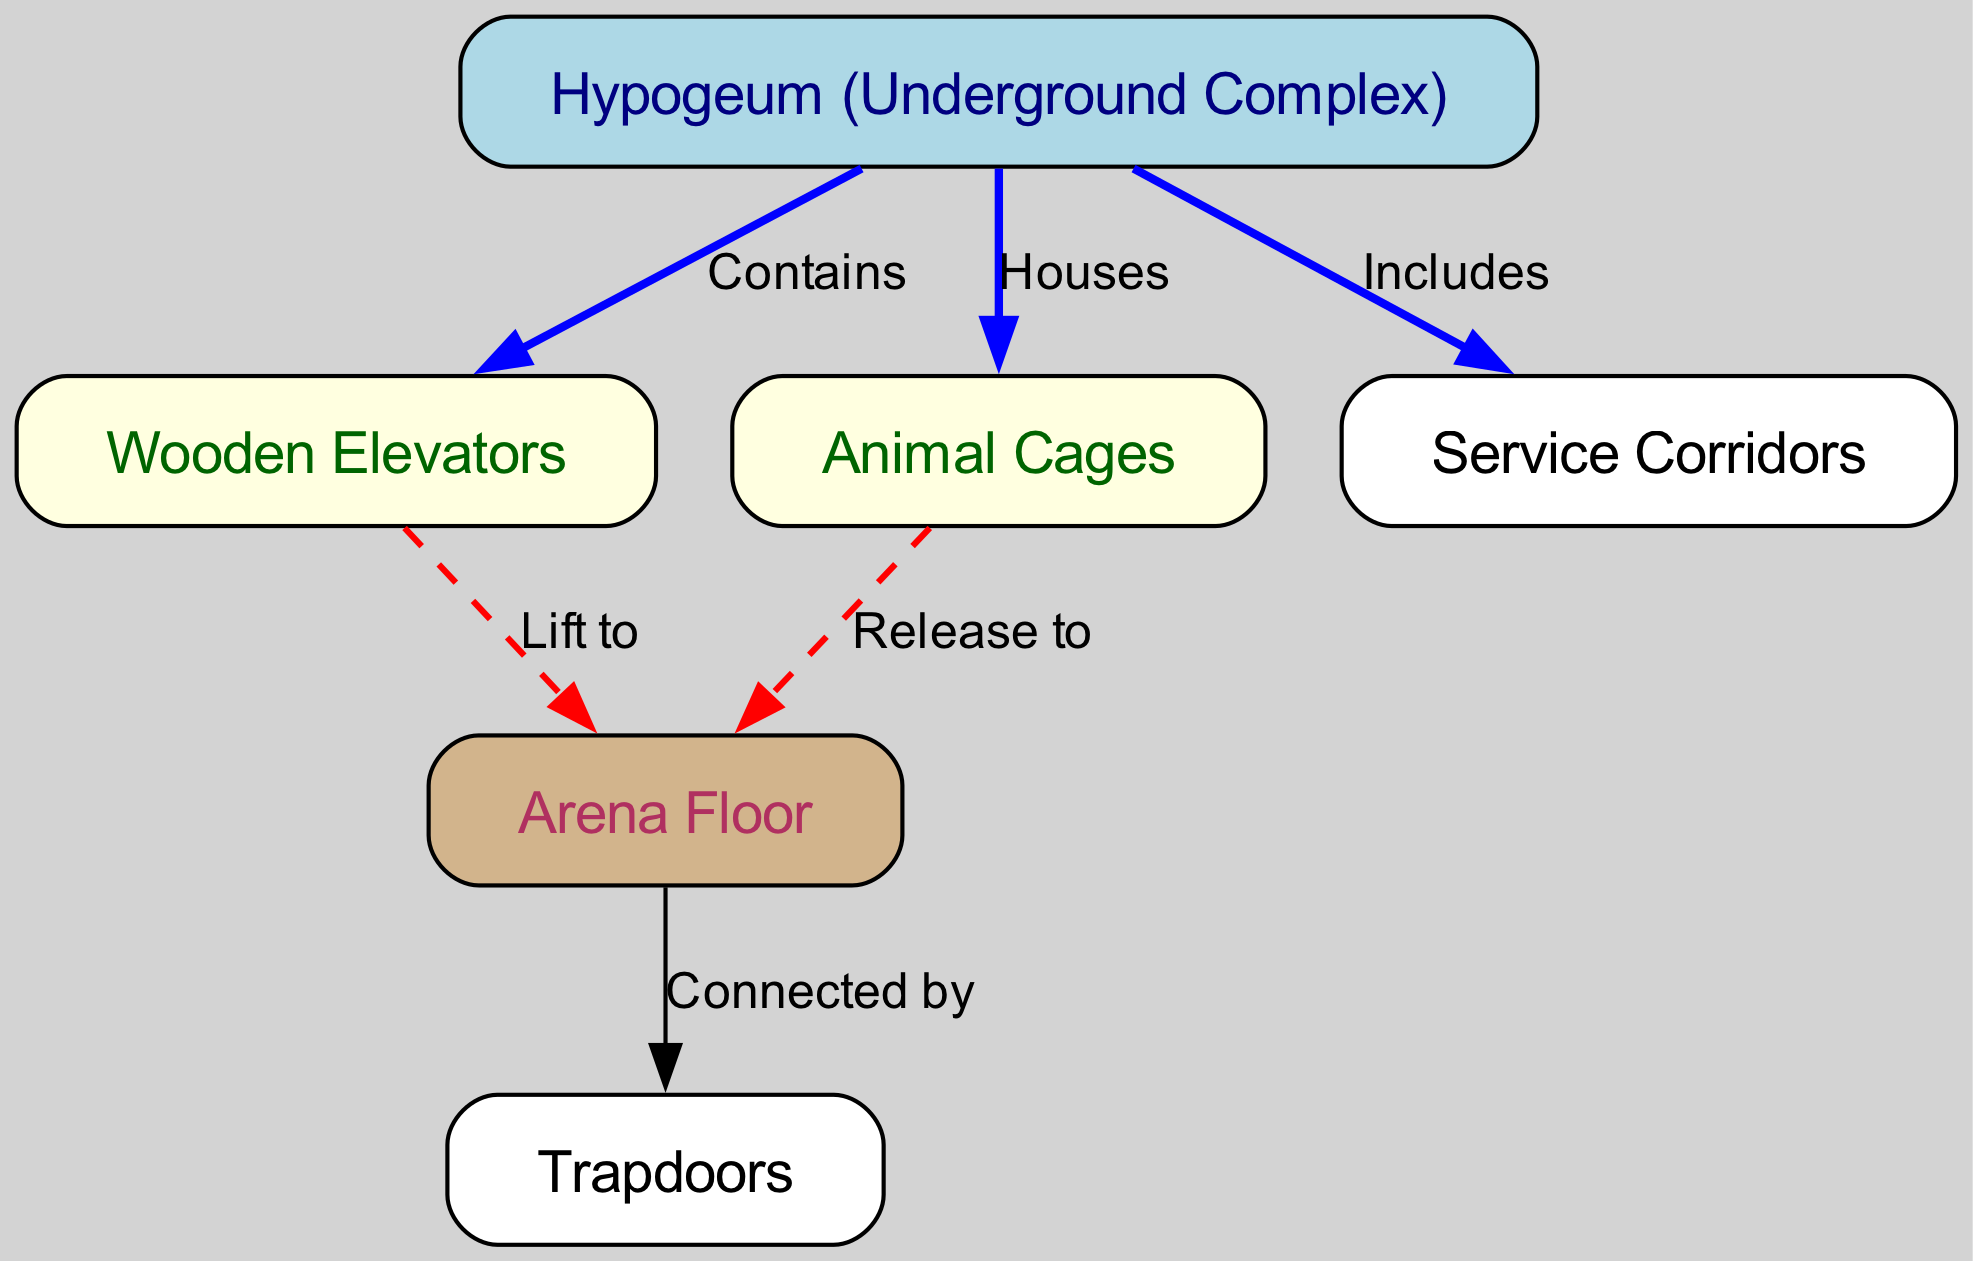What is the main function of the hypogeum? The hypogeum is the underground complex that houses both the animal cages and the wooden elevators, making it the central feature of the diagram.
Answer: Underground Complex How many nodes are present in the diagram? The diagram contains six nodes: hypogeum, wooden elevators, animal cages, service corridors, arena floor, and trapdoors.
Answer: Six What does the hypogeum include? The hypogeum includes service corridors, which are shown as a direct relationship in the diagram.
Answer: Service Corridors What type of system do the wooden elevators serve? The wooden elevators serve the function of lifting to the arena floor, as indicated by their connection in the diagram.
Answer: Lifting How are the animal cages connected to the arena? The animal cages are connected to the arena by the action of releasing animals, as shown by the labeled edge in the diagram.
Answer: Release to What color represents the hypogeum in the diagram? The hypogeum is represented in light blue color in the diagram, distinguishing it from other elements.
Answer: Light Blue Which elements in the hypogeum directly interface with the arena floor? The elements that directly interface with the arena floor are the wooden elevators and the animal cages, both having distinct labeled relationships to the arena.
Answer: Elevators and Cages What is the relationship between the arena and trapdoors? The arena is connected to the trapdoors by the relationship denoted in the diagram, indicating a direct connection for functionalities such as animal releases.
Answer: Connected by Which element contains the elevators? The hypogeum contains the wooden elevators as indicated by the labeled edge in the diagram.
Answer: Contains 